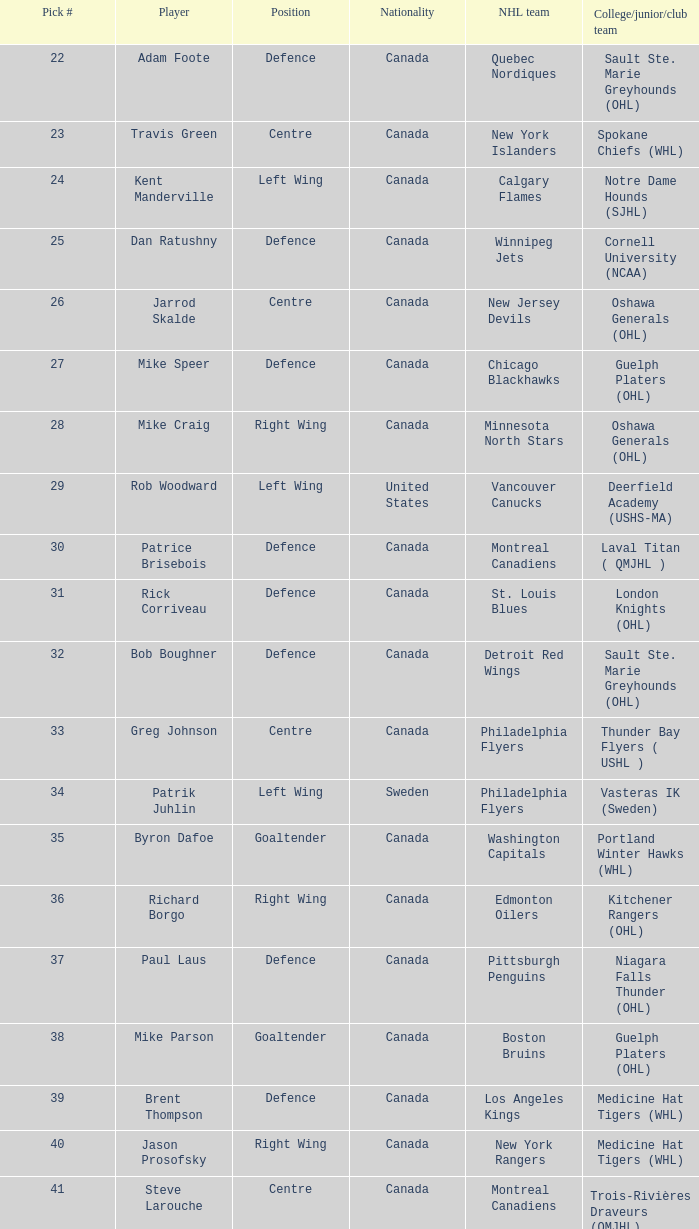What nhl team drafted richard borgo? Edmonton Oilers. 